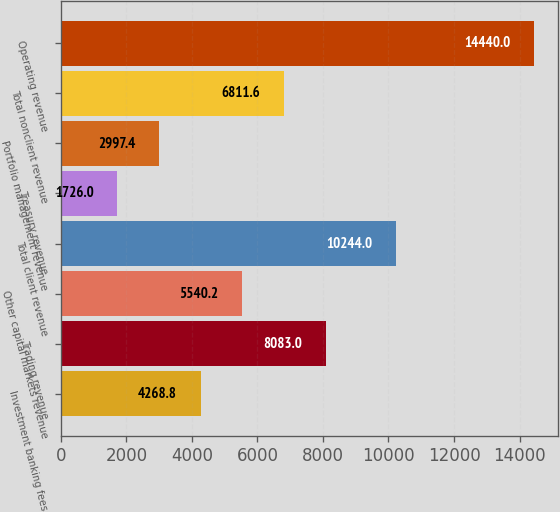Convert chart to OTSL. <chart><loc_0><loc_0><loc_500><loc_500><bar_chart><fcel>Investment banking fees<fcel>Trading revenue<fcel>Other capital markets revenue<fcel>Total client revenue<fcel>Treasury revenue<fcel>Portfolio management revenue<fcel>Total nonclient revenue<fcel>Operating revenue<nl><fcel>4268.8<fcel>8083<fcel>5540.2<fcel>10244<fcel>1726<fcel>2997.4<fcel>6811.6<fcel>14440<nl></chart> 